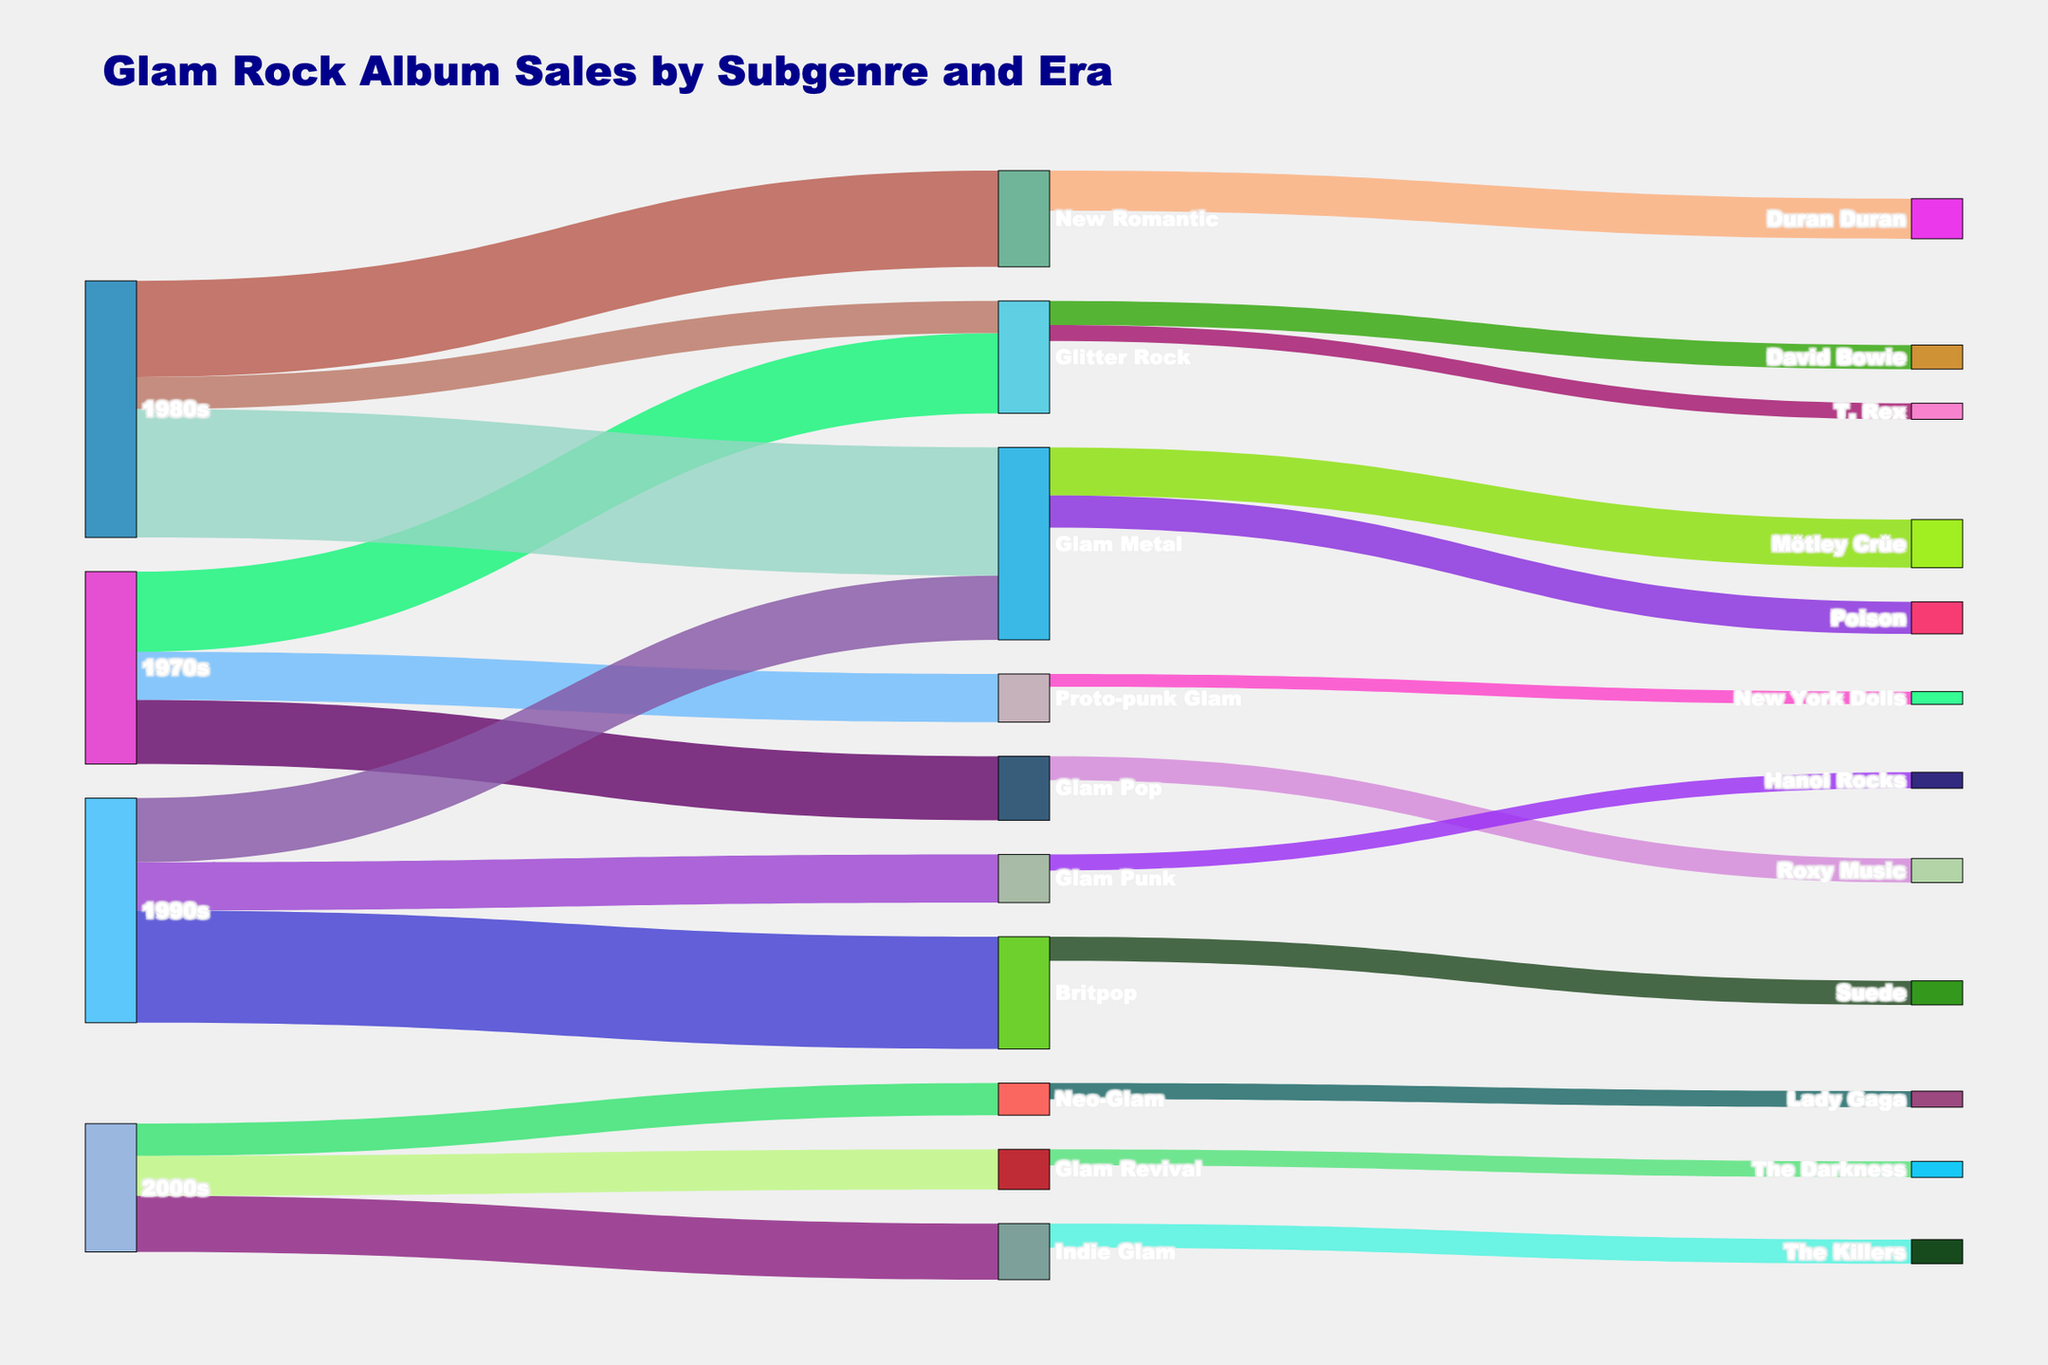What is the most popular subgenre in the 1970s in terms of album sales? The figure shows the connections from decades to subgenres with album sales. By examining the values, "Glitter Rock" has the highest value at 500,000 in the 1970s.
Answer: Glitter Rock Which artist has the highest album sales in the "Glam Metal" subgenre? The diagram shows the connections from "Glam Metal" to various artists with the respective album sales. "Mötley Crüe" has the highest sales at 300,000.
Answer: Mötley Crüe How many total album sales were recorded in the 1990s across all subgenres? Summing up the values connected to the 1990s: 400,000 (Glam Metal) + 700,000 (Britpop) + 300,000 (Glam Punk) = 1,400,000.
Answer: 1,400,000 How does the popularity of "Glitter Rock" change from the 1970s to the 1980s in terms of album sales? The Sankey Diagram shows "Glitter Rock" with 500,000 sales in the 1970s and 200,000 sales in the 1980s. The difference is 500,000 - 200,000 = 300,000.
Answer: Decreased by 300,000 Which subgenre emerges in the 2000s that was not present in earlier decades? By examining the subgenres connected to the 2000s, "Glam Revival", "Indie Glam", and "Neo-Glam" appear. Cross-referencing with previous decades, we see they are new.
Answer: Glam Revival, Indie Glam, Neo-Glam How do the album sales of "Duran Duran" in "New Romantic" compare to "The Darkness" in "Glam Revival"? The figure links "Duran Duran" to 250,000 sales and "The Darkness" to 100,000 sales. Comparing these values, "Duran Duran" has higher sales by 250,000 - 100,000 = 150,000.
Answer: Duran Duran is higher by 150,000 Which era does "T. Rex" belong to in terms of album sales? The Sankey Diagram links "T. Rex" to "Glitter Rock", and "Glitter Rock" to the 1970s. Hence, "T. Rex" belongs to the 1970s.
Answer: 1970s What is the total album sales for "David Bowie" and "Lady Gaga"? The diagram shows "David Bowie" with 150,000 sales and "Lady Gaga" with 100,000 sales. Adding these together gives 150,000 + 100,000 = 250,000.
Answer: 250,000 